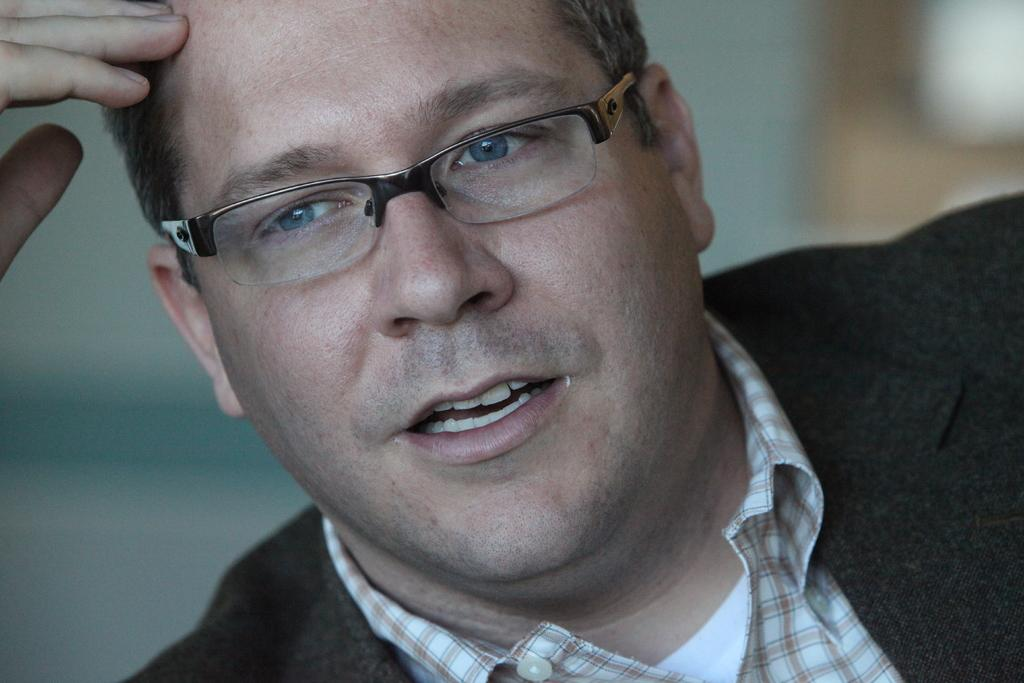Who is present in the image? There is a man in the image. What can be observed about the man's appearance? The man is wearing spectacles. Can you describe the background of the image? The background of the image is blurry. What type of low verse does the man in the image believe in? There is no indication in the image of the man's beliefs or any verses, so it cannot be determined from the picture. 